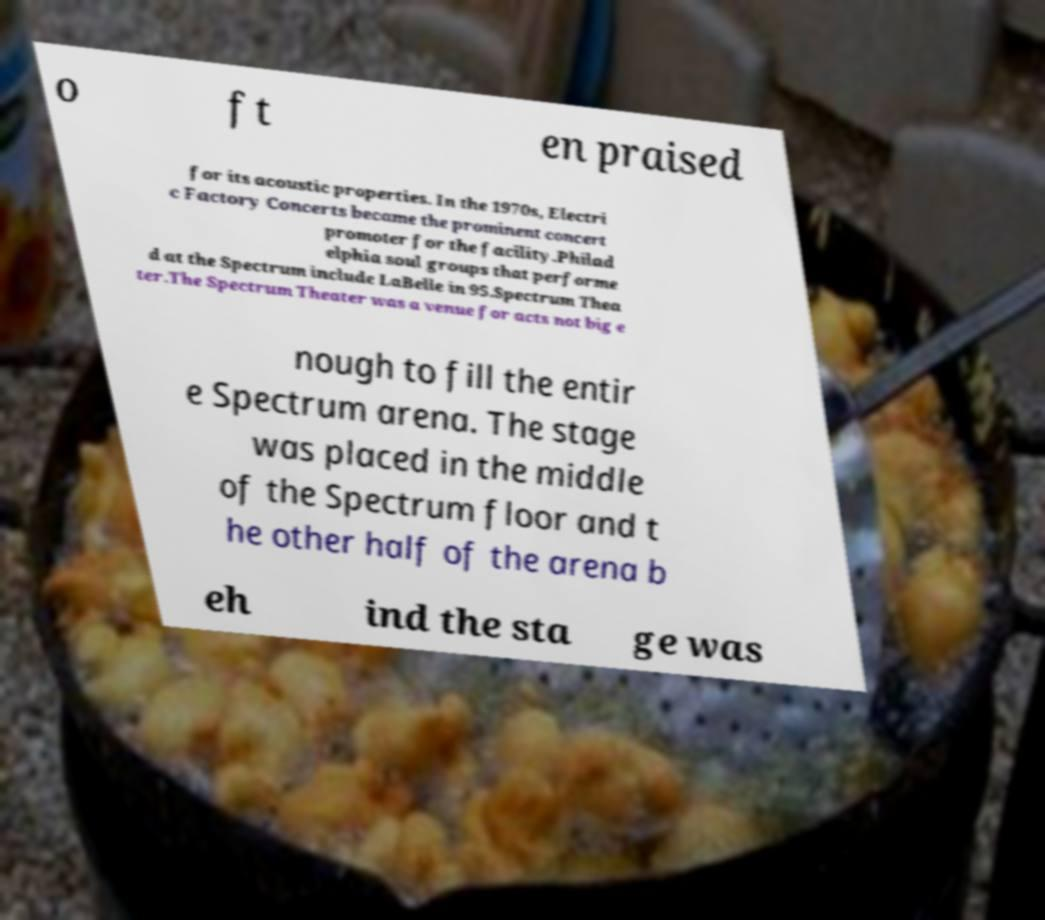Could you extract and type out the text from this image? o ft en praised for its acoustic properties. In the 1970s, Electri c Factory Concerts became the prominent concert promoter for the facility.Philad elphia soul groups that performe d at the Spectrum include LaBelle in 95.Spectrum Thea ter.The Spectrum Theater was a venue for acts not big e nough to fill the entir e Spectrum arena. The stage was placed in the middle of the Spectrum floor and t he other half of the arena b eh ind the sta ge was 